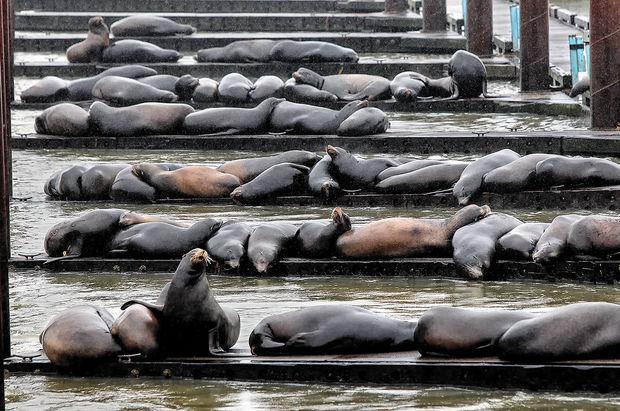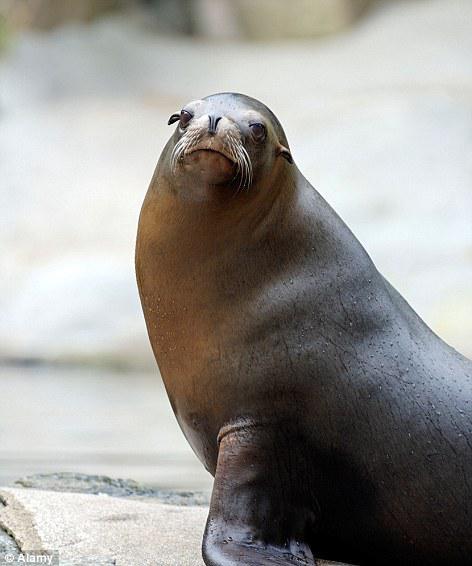The first image is the image on the left, the second image is the image on the right. Considering the images on both sides, is "An image contains no more than one seal." valid? Answer yes or no. Yes. The first image is the image on the left, the second image is the image on the right. For the images displayed, is the sentence "Some of the sea lions have markings made by humans on them." factually correct? Answer yes or no. No. 